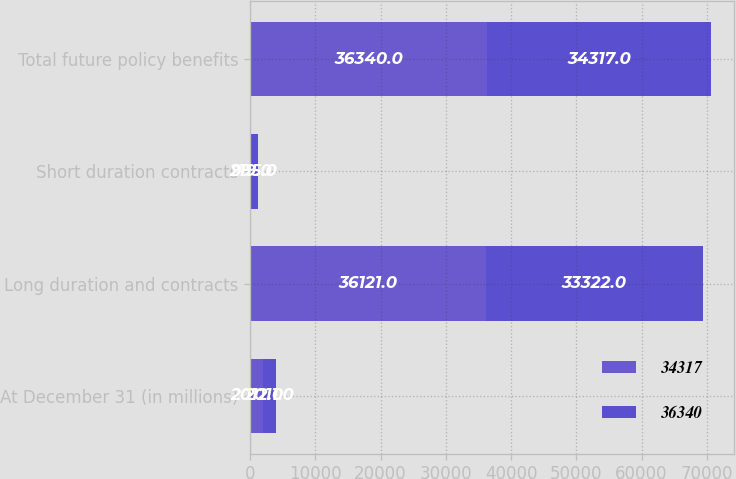<chart> <loc_0><loc_0><loc_500><loc_500><stacked_bar_chart><ecel><fcel>At December 31 (in millions)<fcel>Long duration and contracts<fcel>Short duration contracts<fcel>Total future policy benefits<nl><fcel>34317<fcel>2012<fcel>36121<fcel>219<fcel>36340<nl><fcel>36340<fcel>2011<fcel>33322<fcel>995<fcel>34317<nl></chart> 